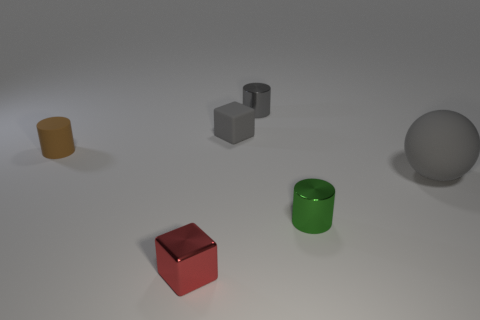Subtract 1 cylinders. How many cylinders are left? 2 Subtract all metallic cylinders. How many cylinders are left? 1 Subtract all blocks. How many objects are left? 4 Subtract all matte cylinders. Subtract all gray metal objects. How many objects are left? 4 Add 5 gray metal things. How many gray metal things are left? 6 Add 3 small brown objects. How many small brown objects exist? 4 Add 2 tiny yellow objects. How many objects exist? 8 Subtract all gray cylinders. How many cylinders are left? 2 Subtract 0 green balls. How many objects are left? 6 Subtract all red balls. Subtract all red blocks. How many balls are left? 1 